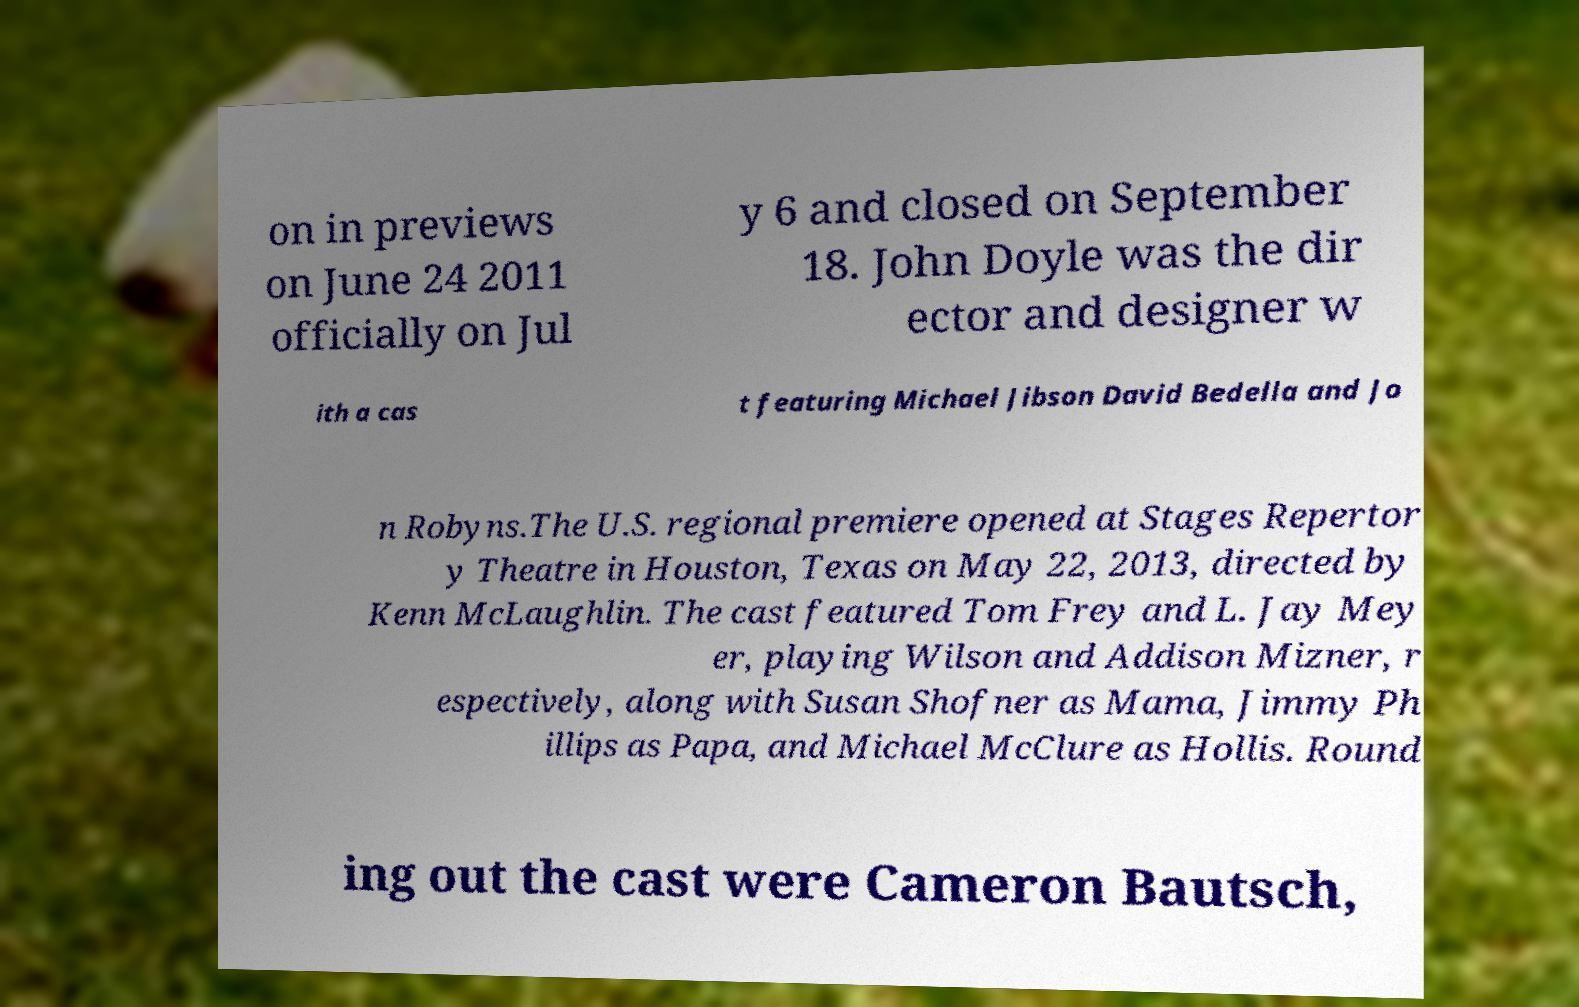I need the written content from this picture converted into text. Can you do that? on in previews on June 24 2011 officially on Jul y 6 and closed on September 18. John Doyle was the dir ector and designer w ith a cas t featuring Michael Jibson David Bedella and Jo n Robyns.The U.S. regional premiere opened at Stages Repertor y Theatre in Houston, Texas on May 22, 2013, directed by Kenn McLaughlin. The cast featured Tom Frey and L. Jay Mey er, playing Wilson and Addison Mizner, r espectively, along with Susan Shofner as Mama, Jimmy Ph illips as Papa, and Michael McClure as Hollis. Round ing out the cast were Cameron Bautsch, 